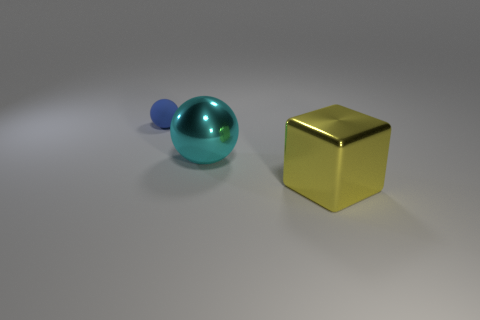Add 1 large green shiny cubes. How many objects exist? 4 Subtract all cyan spheres. How many spheres are left? 1 Subtract all blocks. How many objects are left? 2 Add 3 large metallic cubes. How many large metallic cubes exist? 4 Subtract 0 gray balls. How many objects are left? 3 Subtract 1 spheres. How many spheres are left? 1 Subtract all blue cubes. Subtract all red cylinders. How many cubes are left? 1 Subtract all small spheres. Subtract all small blue spheres. How many objects are left? 1 Add 1 metal cubes. How many metal cubes are left? 2 